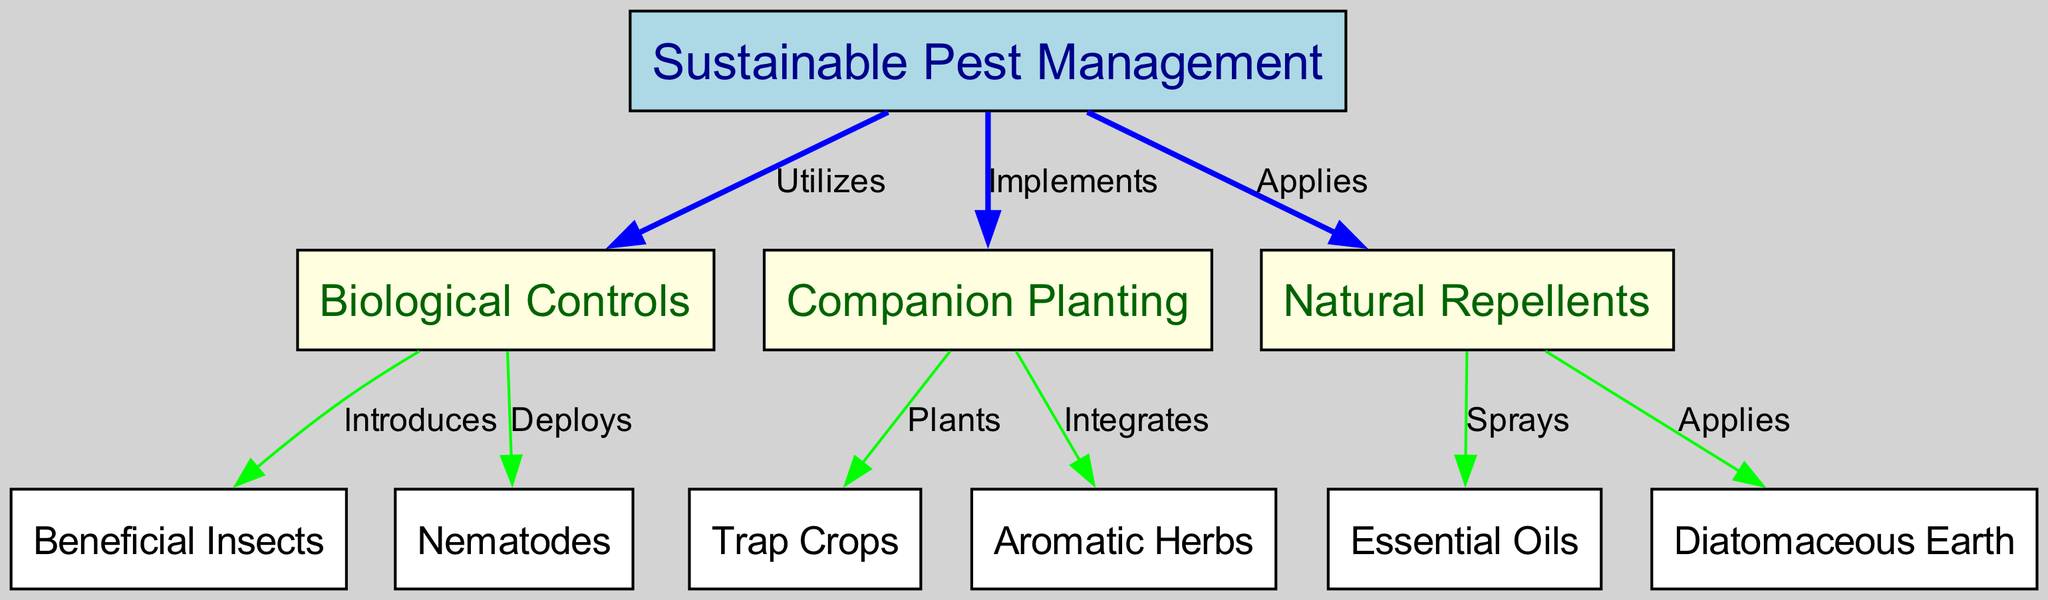What is the main topic of the diagram? The main topic of the diagram is labeled as "Sustainable Pest Management" in the top node, indicating the focus of the entire flowchart.
Answer: Sustainable Pest Management How many primary techniques are utilized in sustainable pest management? The diagram features three primary techniques branching from the main topic: Biological Controls, Companion Planting, and Natural Repellents. Each is represented by a direct edge from the main node.
Answer: Three Which beneficial insect is introduced under Biological Controls? The node labeled "Beneficial Insects" is directly connected to "Biological Controls", indicating that it is a specific component introduced within this category.
Answer: Beneficial Insects What type of planting does Companion Planting implement? The edge labeled "Plants" from "Companion Planting" leads to "Trap Crops", indicating that it specifically implements this type of planting as part of its strategies.
Answer: Trap Crops What two natural repellents are applied according to the diagram? The diagram shows edges leading from "Natural Repellents" to "Essential Oils" and "Diatomaceous Earth", indicating these two specific natural repellents used in sustainable pest management.
Answer: Essential Oils, Diatomaceous Earth How do Biological Controls relate to Nematodes? The edge labeled "Deploys" connects "Biological Controls" to "Nematodes", indicating that Nematodes are a specific biological control technique being deployed within the broader category.
Answer: Deploys Which relationship is shown between Companion Planting and Aromatic Herbs? The diagram shows an edge labeled "Integrates" that connects "Companion Planting" to "Aromatic Herbs", indicating a relationship where Companion Planting incorporates the use of Aromatic Herbs.
Answer: Integrates What color represents the main node in the diagram? The main node labeled "Sustainable Pest Management" is filled with light blue color, clearly distinguishing it as the primary focus of the diagram.
Answer: Light blue 